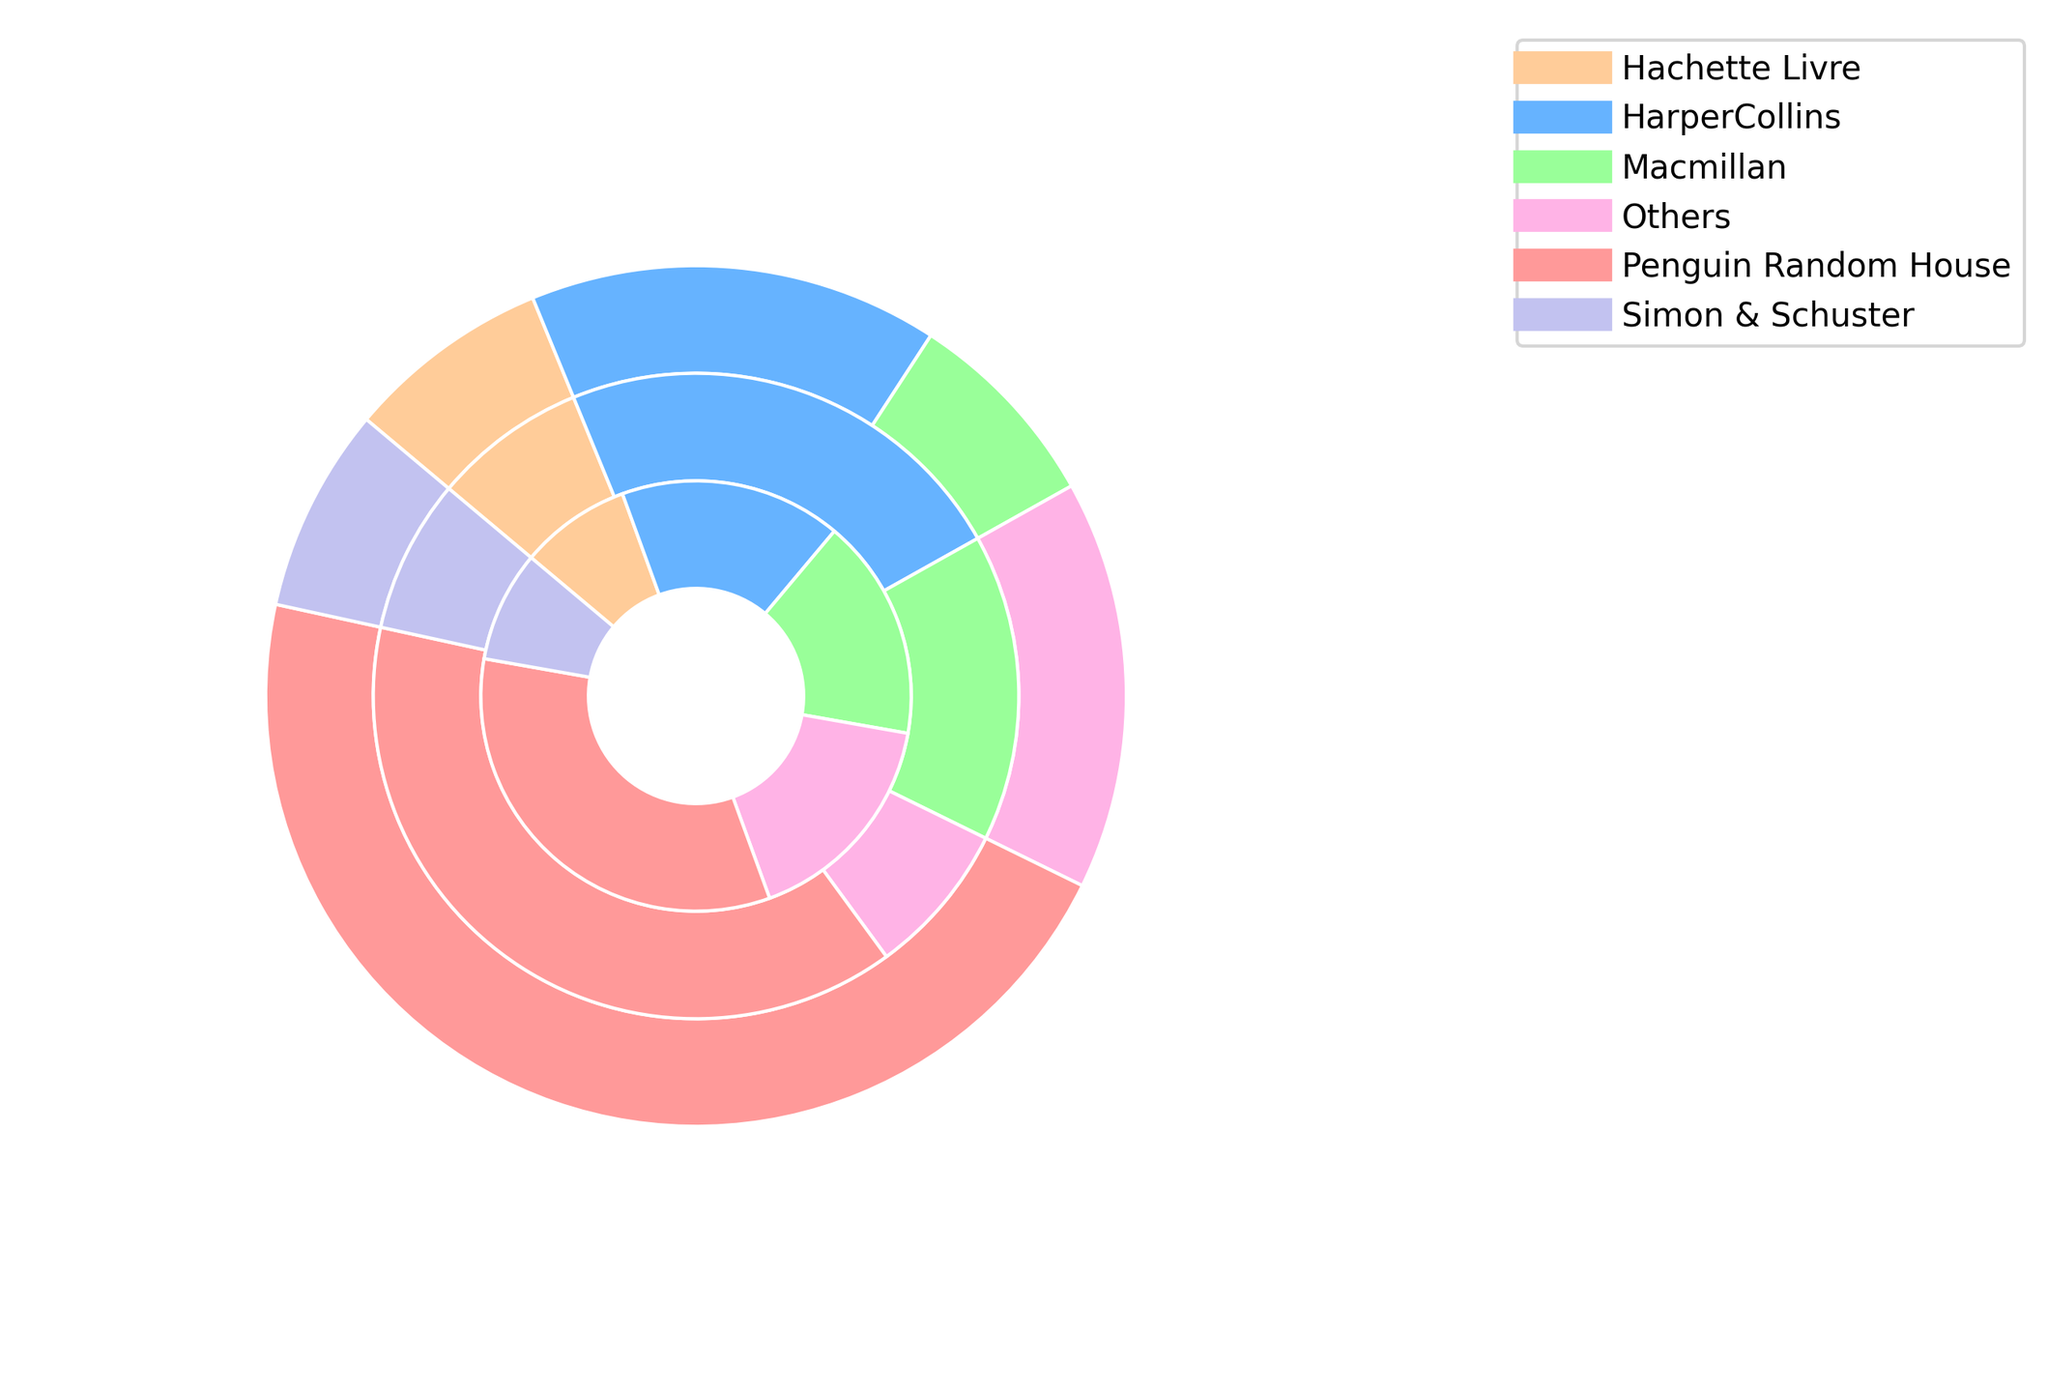What is the most dominant genre for Penguin Random House? Look at the sections corresponding to Penguin Random House and compare the sizes for Fiction, Non-Fiction, and Children. Children has the largest section.
Answer: Children How much larger is HarperCollins' market share for Fiction compared to Macmillan's market share for Fiction? Compare the market share segments for Fiction under HarperCollins and Macmillan. HarperCollins has 15% and Macmillan has 10%. The difference is 15% - 10%.
Answer: 5% What is the total market share of Non-Fiction for all publishers combined? Sum the Non-Fiction market share percentages for all publishers: 20% (Penguin Random House) + 10% (HarperCollins) + 10% (Macmillan) + 5% (Hachette Livre) + 5% (Simon & Schuster) + 10% (Others).
Answer: 60% Which publisher has the smallest market share for Children’s books, and what is that share? Compare the sizes of the Children section for all publishers. Hachette Livre, Simon & Schuster, and Macmillan each have the smallest section (5%).
Answer: Hachette Livre, Simon & Schuster, Macmillan; 5% Is the market share for Penguin Random House’s Non-Fiction larger or smaller than the total market share for Hachette Livre across all genres? Compare Penguin Random House's Non-Fiction market share (20%) with the sum of Hachette Livre's shares (5% + 5% + 5% = 15%).
Answer: Larger What is the ratio of the market share of Fiction to Non-Fiction for Penguin Random House? Compare the market share sizes for Fiction (25%) and Non-Fiction (20%) for Penguin Random House and compute the ratio 25/20.
Answer: 1.25 How does the market share of “Others” in Non-Fiction compare to their market share in Children’s books? Compare the Non-Fiction and Children segments for the “Others” publisher. Both have 10%.
Answer: Equal What is the average market share for Macmillan across all the genres? Sum Macmillan's market shares (10% Fiction + 10% Non-Fiction + 5% Children) and divide by the number of genres (3).
Answer: 8.33% Which genre has the highest overall market share across all publishers? Sum the market shares for all publishers for each genre. Compare the totals of Fiction, Non-Fiction, and Children. Children will have the highest total.
Answer: Children 